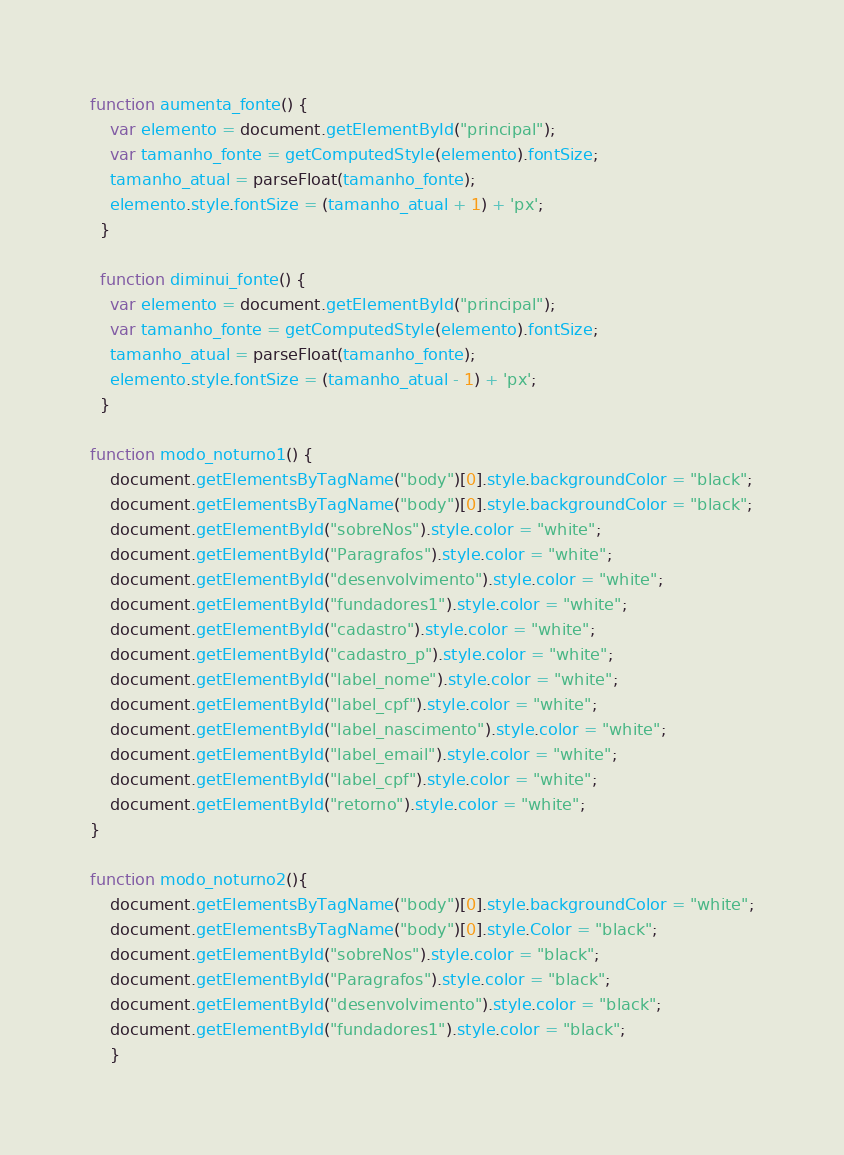Convert code to text. <code><loc_0><loc_0><loc_500><loc_500><_JavaScript_>function aumenta_fonte() {
    var elemento = document.getElementById("principal");
    var tamanho_fonte = getComputedStyle(elemento).fontSize;
    tamanho_atual = parseFloat(tamanho_fonte);
    elemento.style.fontSize = (tamanho_atual + 1) + 'px';
  }
  
  function diminui_fonte() {
    var elemento = document.getElementById("principal");
    var tamanho_fonte = getComputedStyle(elemento).fontSize;
    tamanho_atual = parseFloat(tamanho_fonte);
    elemento.style.fontSize = (tamanho_atual - 1) + 'px';
  }

function modo_noturno1() {
    document.getElementsByTagName("body")[0].style.backgroundColor = "black";
    document.getElementsByTagName("body")[0].style.backgroundColor = "black";
    document.getElementById("sobreNos").style.color = "white";
    document.getElementById("Paragrafos").style.color = "white";
    document.getElementById("desenvolvimento").style.color = "white";
    document.getElementById("fundadores1").style.color = "white";
    document.getElementById("cadastro").style.color = "white";
    document.getElementById("cadastro_p").style.color = "white";
    document.getElementById("label_nome").style.color = "white";
    document.getElementById("label_cpf").style.color = "white";
    document.getElementById("label_nascimento").style.color = "white";
    document.getElementById("label_email").style.color = "white";
    document.getElementById("label_cpf").style.color = "white";
    document.getElementById("retorno").style.color = "white";
}

function modo_noturno2(){
    document.getElementsByTagName("body")[0].style.backgroundColor = "white";
    document.getElementsByTagName("body")[0].style.Color = "black";
    document.getElementById("sobreNos").style.color = "black";
    document.getElementById("Paragrafos").style.color = "black";
    document.getElementById("desenvolvimento").style.color = "black";
    document.getElementById("fundadores1").style.color = "black";
    }
</code> 